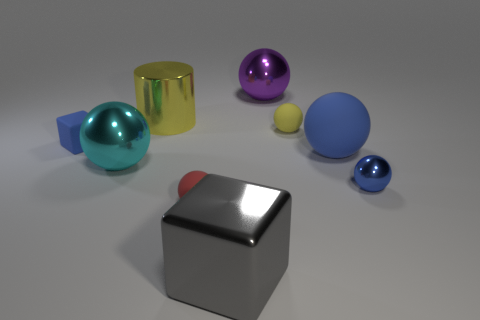Subtract all big purple spheres. How many spheres are left? 5 Subtract all green cylinders. How many blue balls are left? 2 Subtract all yellow balls. How many balls are left? 5 Add 3 big cyan metallic balls. How many big cyan metallic balls exist? 4 Subtract 0 purple cylinders. How many objects are left? 9 Subtract all balls. How many objects are left? 3 Subtract all purple cylinders. Subtract all blue spheres. How many cylinders are left? 1 Subtract all spheres. Subtract all large purple things. How many objects are left? 2 Add 9 large yellow metallic things. How many large yellow metallic things are left? 10 